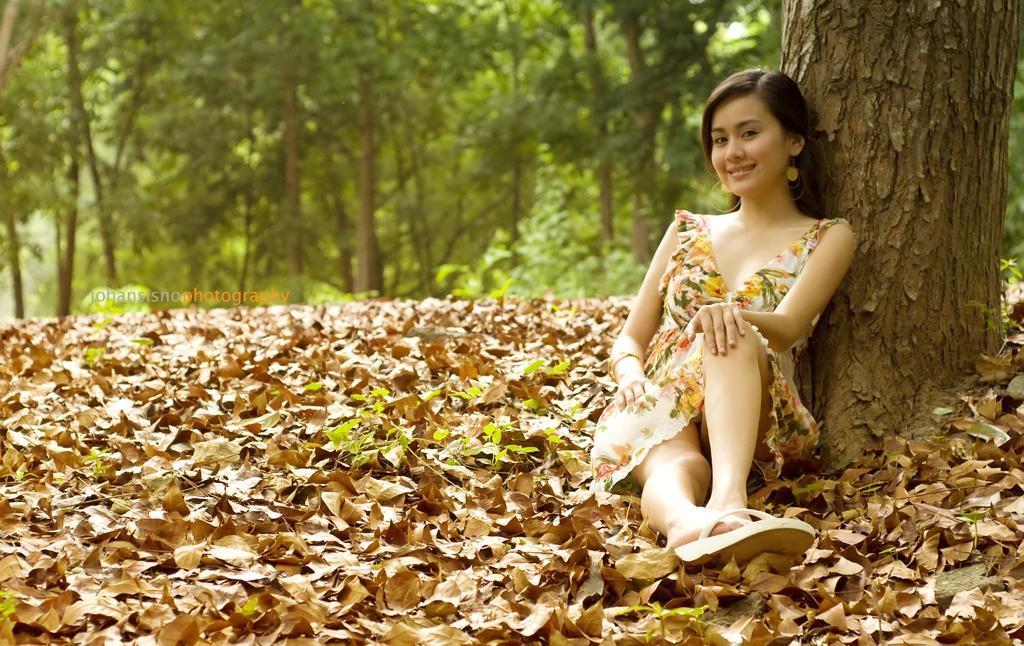Describe this image in one or two sentences. In this image we can see a lady. There are many trees and dry leaves in the image. There is a trunk of the tree at the right side of the image. 